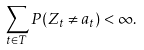<formula> <loc_0><loc_0><loc_500><loc_500>\sum _ { t \in T } P ( Z _ { t } \not = a _ { t } ) < \infty .</formula> 